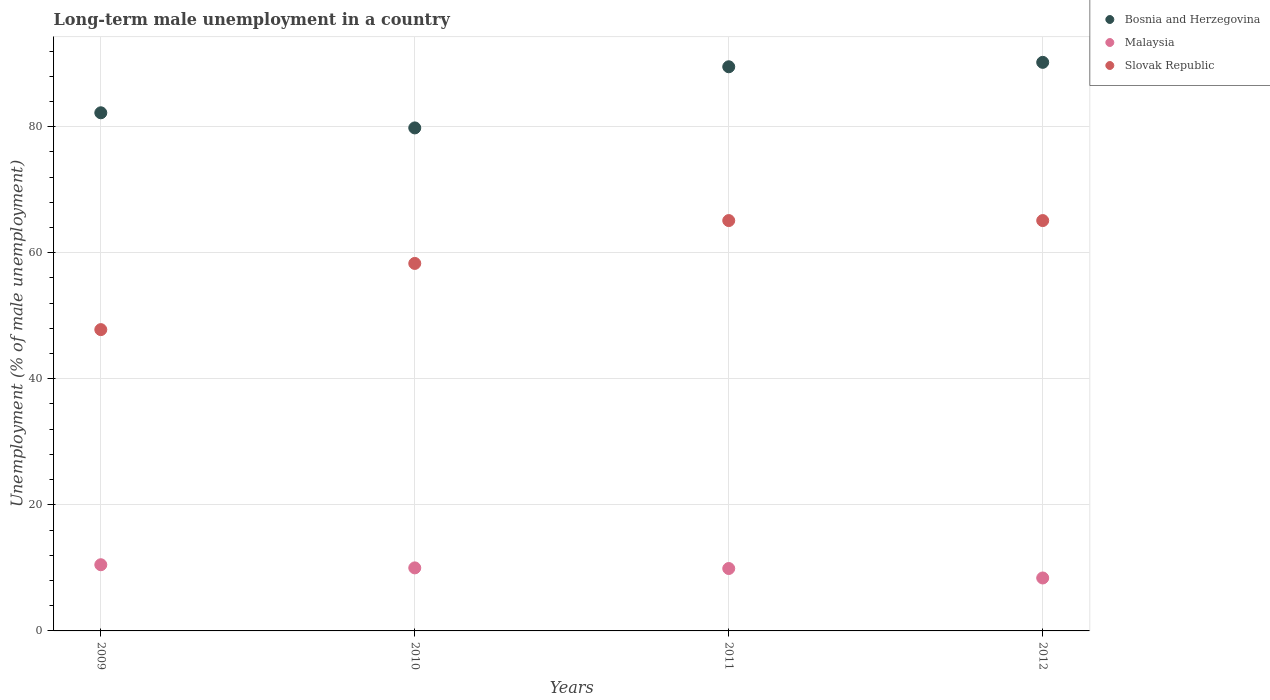How many different coloured dotlines are there?
Your response must be concise. 3. What is the percentage of long-term unemployed male population in Bosnia and Herzegovina in 2010?
Offer a very short reply. 79.8. Across all years, what is the maximum percentage of long-term unemployed male population in Slovak Republic?
Your answer should be very brief. 65.1. Across all years, what is the minimum percentage of long-term unemployed male population in Bosnia and Herzegovina?
Ensure brevity in your answer.  79.8. In which year was the percentage of long-term unemployed male population in Bosnia and Herzegovina maximum?
Provide a short and direct response. 2012. What is the total percentage of long-term unemployed male population in Bosnia and Herzegovina in the graph?
Give a very brief answer. 341.7. What is the difference between the percentage of long-term unemployed male population in Slovak Republic in 2009 and that in 2011?
Give a very brief answer. -17.3. What is the difference between the percentage of long-term unemployed male population in Malaysia in 2010 and the percentage of long-term unemployed male population in Slovak Republic in 2012?
Your response must be concise. -55.1. What is the average percentage of long-term unemployed male population in Slovak Republic per year?
Offer a terse response. 59.07. In the year 2012, what is the difference between the percentage of long-term unemployed male population in Bosnia and Herzegovina and percentage of long-term unemployed male population in Malaysia?
Offer a terse response. 81.8. In how many years, is the percentage of long-term unemployed male population in Bosnia and Herzegovina greater than 44 %?
Your answer should be compact. 4. What is the ratio of the percentage of long-term unemployed male population in Slovak Republic in 2009 to that in 2011?
Provide a short and direct response. 0.73. Is the percentage of long-term unemployed male population in Slovak Republic in 2009 less than that in 2011?
Provide a short and direct response. Yes. What is the difference between the highest and the second highest percentage of long-term unemployed male population in Bosnia and Herzegovina?
Give a very brief answer. 0.7. What is the difference between the highest and the lowest percentage of long-term unemployed male population in Slovak Republic?
Give a very brief answer. 17.3. Is it the case that in every year, the sum of the percentage of long-term unemployed male population in Bosnia and Herzegovina and percentage of long-term unemployed male population in Slovak Republic  is greater than the percentage of long-term unemployed male population in Malaysia?
Your answer should be very brief. Yes. Is the percentage of long-term unemployed male population in Malaysia strictly less than the percentage of long-term unemployed male population in Bosnia and Herzegovina over the years?
Offer a terse response. Yes. How many years are there in the graph?
Keep it short and to the point. 4. Are the values on the major ticks of Y-axis written in scientific E-notation?
Provide a short and direct response. No. Does the graph contain any zero values?
Provide a short and direct response. No. Does the graph contain grids?
Provide a succinct answer. Yes. Where does the legend appear in the graph?
Offer a very short reply. Top right. What is the title of the graph?
Provide a succinct answer. Long-term male unemployment in a country. Does "Paraguay" appear as one of the legend labels in the graph?
Your answer should be compact. No. What is the label or title of the Y-axis?
Your answer should be compact. Unemployment (% of male unemployment). What is the Unemployment (% of male unemployment) of Bosnia and Herzegovina in 2009?
Make the answer very short. 82.2. What is the Unemployment (% of male unemployment) in Malaysia in 2009?
Provide a short and direct response. 10.5. What is the Unemployment (% of male unemployment) in Slovak Republic in 2009?
Your answer should be very brief. 47.8. What is the Unemployment (% of male unemployment) of Bosnia and Herzegovina in 2010?
Offer a very short reply. 79.8. What is the Unemployment (% of male unemployment) in Slovak Republic in 2010?
Give a very brief answer. 58.3. What is the Unemployment (% of male unemployment) in Bosnia and Herzegovina in 2011?
Your answer should be very brief. 89.5. What is the Unemployment (% of male unemployment) of Malaysia in 2011?
Provide a short and direct response. 9.9. What is the Unemployment (% of male unemployment) of Slovak Republic in 2011?
Keep it short and to the point. 65.1. What is the Unemployment (% of male unemployment) in Bosnia and Herzegovina in 2012?
Give a very brief answer. 90.2. What is the Unemployment (% of male unemployment) of Malaysia in 2012?
Offer a terse response. 8.4. What is the Unemployment (% of male unemployment) in Slovak Republic in 2012?
Provide a short and direct response. 65.1. Across all years, what is the maximum Unemployment (% of male unemployment) in Bosnia and Herzegovina?
Offer a very short reply. 90.2. Across all years, what is the maximum Unemployment (% of male unemployment) of Slovak Republic?
Keep it short and to the point. 65.1. Across all years, what is the minimum Unemployment (% of male unemployment) in Bosnia and Herzegovina?
Offer a very short reply. 79.8. Across all years, what is the minimum Unemployment (% of male unemployment) of Malaysia?
Offer a very short reply. 8.4. Across all years, what is the minimum Unemployment (% of male unemployment) in Slovak Republic?
Your answer should be very brief. 47.8. What is the total Unemployment (% of male unemployment) of Bosnia and Herzegovina in the graph?
Your answer should be very brief. 341.7. What is the total Unemployment (% of male unemployment) of Malaysia in the graph?
Offer a terse response. 38.8. What is the total Unemployment (% of male unemployment) in Slovak Republic in the graph?
Provide a succinct answer. 236.3. What is the difference between the Unemployment (% of male unemployment) in Slovak Republic in 2009 and that in 2010?
Provide a short and direct response. -10.5. What is the difference between the Unemployment (% of male unemployment) of Slovak Republic in 2009 and that in 2011?
Offer a terse response. -17.3. What is the difference between the Unemployment (% of male unemployment) of Slovak Republic in 2009 and that in 2012?
Give a very brief answer. -17.3. What is the difference between the Unemployment (% of male unemployment) of Bosnia and Herzegovina in 2010 and that in 2011?
Your response must be concise. -9.7. What is the difference between the Unemployment (% of male unemployment) in Malaysia in 2010 and that in 2011?
Ensure brevity in your answer.  0.1. What is the difference between the Unemployment (% of male unemployment) of Slovak Republic in 2010 and that in 2011?
Your answer should be compact. -6.8. What is the difference between the Unemployment (% of male unemployment) of Bosnia and Herzegovina in 2010 and that in 2012?
Ensure brevity in your answer.  -10.4. What is the difference between the Unemployment (% of male unemployment) of Malaysia in 2010 and that in 2012?
Your answer should be compact. 1.6. What is the difference between the Unemployment (% of male unemployment) of Bosnia and Herzegovina in 2011 and that in 2012?
Provide a succinct answer. -0.7. What is the difference between the Unemployment (% of male unemployment) of Bosnia and Herzegovina in 2009 and the Unemployment (% of male unemployment) of Malaysia in 2010?
Give a very brief answer. 72.2. What is the difference between the Unemployment (% of male unemployment) in Bosnia and Herzegovina in 2009 and the Unemployment (% of male unemployment) in Slovak Republic in 2010?
Your answer should be very brief. 23.9. What is the difference between the Unemployment (% of male unemployment) of Malaysia in 2009 and the Unemployment (% of male unemployment) of Slovak Republic in 2010?
Make the answer very short. -47.8. What is the difference between the Unemployment (% of male unemployment) in Bosnia and Herzegovina in 2009 and the Unemployment (% of male unemployment) in Malaysia in 2011?
Your answer should be compact. 72.3. What is the difference between the Unemployment (% of male unemployment) in Bosnia and Herzegovina in 2009 and the Unemployment (% of male unemployment) in Slovak Republic in 2011?
Provide a short and direct response. 17.1. What is the difference between the Unemployment (% of male unemployment) of Malaysia in 2009 and the Unemployment (% of male unemployment) of Slovak Republic in 2011?
Provide a succinct answer. -54.6. What is the difference between the Unemployment (% of male unemployment) of Bosnia and Herzegovina in 2009 and the Unemployment (% of male unemployment) of Malaysia in 2012?
Offer a terse response. 73.8. What is the difference between the Unemployment (% of male unemployment) in Malaysia in 2009 and the Unemployment (% of male unemployment) in Slovak Republic in 2012?
Offer a terse response. -54.6. What is the difference between the Unemployment (% of male unemployment) of Bosnia and Herzegovina in 2010 and the Unemployment (% of male unemployment) of Malaysia in 2011?
Your answer should be very brief. 69.9. What is the difference between the Unemployment (% of male unemployment) of Bosnia and Herzegovina in 2010 and the Unemployment (% of male unemployment) of Slovak Republic in 2011?
Give a very brief answer. 14.7. What is the difference between the Unemployment (% of male unemployment) of Malaysia in 2010 and the Unemployment (% of male unemployment) of Slovak Republic in 2011?
Ensure brevity in your answer.  -55.1. What is the difference between the Unemployment (% of male unemployment) in Bosnia and Herzegovina in 2010 and the Unemployment (% of male unemployment) in Malaysia in 2012?
Keep it short and to the point. 71.4. What is the difference between the Unemployment (% of male unemployment) in Bosnia and Herzegovina in 2010 and the Unemployment (% of male unemployment) in Slovak Republic in 2012?
Make the answer very short. 14.7. What is the difference between the Unemployment (% of male unemployment) of Malaysia in 2010 and the Unemployment (% of male unemployment) of Slovak Republic in 2012?
Your response must be concise. -55.1. What is the difference between the Unemployment (% of male unemployment) in Bosnia and Herzegovina in 2011 and the Unemployment (% of male unemployment) in Malaysia in 2012?
Give a very brief answer. 81.1. What is the difference between the Unemployment (% of male unemployment) in Bosnia and Herzegovina in 2011 and the Unemployment (% of male unemployment) in Slovak Republic in 2012?
Your answer should be very brief. 24.4. What is the difference between the Unemployment (% of male unemployment) in Malaysia in 2011 and the Unemployment (% of male unemployment) in Slovak Republic in 2012?
Make the answer very short. -55.2. What is the average Unemployment (% of male unemployment) of Bosnia and Herzegovina per year?
Your answer should be compact. 85.42. What is the average Unemployment (% of male unemployment) of Slovak Republic per year?
Your response must be concise. 59.08. In the year 2009, what is the difference between the Unemployment (% of male unemployment) in Bosnia and Herzegovina and Unemployment (% of male unemployment) in Malaysia?
Provide a short and direct response. 71.7. In the year 2009, what is the difference between the Unemployment (% of male unemployment) in Bosnia and Herzegovina and Unemployment (% of male unemployment) in Slovak Republic?
Your answer should be very brief. 34.4. In the year 2009, what is the difference between the Unemployment (% of male unemployment) of Malaysia and Unemployment (% of male unemployment) of Slovak Republic?
Offer a very short reply. -37.3. In the year 2010, what is the difference between the Unemployment (% of male unemployment) of Bosnia and Herzegovina and Unemployment (% of male unemployment) of Malaysia?
Provide a short and direct response. 69.8. In the year 2010, what is the difference between the Unemployment (% of male unemployment) of Bosnia and Herzegovina and Unemployment (% of male unemployment) of Slovak Republic?
Keep it short and to the point. 21.5. In the year 2010, what is the difference between the Unemployment (% of male unemployment) of Malaysia and Unemployment (% of male unemployment) of Slovak Republic?
Offer a very short reply. -48.3. In the year 2011, what is the difference between the Unemployment (% of male unemployment) in Bosnia and Herzegovina and Unemployment (% of male unemployment) in Malaysia?
Provide a succinct answer. 79.6. In the year 2011, what is the difference between the Unemployment (% of male unemployment) of Bosnia and Herzegovina and Unemployment (% of male unemployment) of Slovak Republic?
Provide a succinct answer. 24.4. In the year 2011, what is the difference between the Unemployment (% of male unemployment) of Malaysia and Unemployment (% of male unemployment) of Slovak Republic?
Make the answer very short. -55.2. In the year 2012, what is the difference between the Unemployment (% of male unemployment) of Bosnia and Herzegovina and Unemployment (% of male unemployment) of Malaysia?
Offer a very short reply. 81.8. In the year 2012, what is the difference between the Unemployment (% of male unemployment) of Bosnia and Herzegovina and Unemployment (% of male unemployment) of Slovak Republic?
Ensure brevity in your answer.  25.1. In the year 2012, what is the difference between the Unemployment (% of male unemployment) of Malaysia and Unemployment (% of male unemployment) of Slovak Republic?
Provide a short and direct response. -56.7. What is the ratio of the Unemployment (% of male unemployment) of Bosnia and Herzegovina in 2009 to that in 2010?
Give a very brief answer. 1.03. What is the ratio of the Unemployment (% of male unemployment) in Slovak Republic in 2009 to that in 2010?
Offer a terse response. 0.82. What is the ratio of the Unemployment (% of male unemployment) of Bosnia and Herzegovina in 2009 to that in 2011?
Provide a succinct answer. 0.92. What is the ratio of the Unemployment (% of male unemployment) of Malaysia in 2009 to that in 2011?
Your answer should be compact. 1.06. What is the ratio of the Unemployment (% of male unemployment) of Slovak Republic in 2009 to that in 2011?
Your answer should be compact. 0.73. What is the ratio of the Unemployment (% of male unemployment) in Bosnia and Herzegovina in 2009 to that in 2012?
Your response must be concise. 0.91. What is the ratio of the Unemployment (% of male unemployment) of Slovak Republic in 2009 to that in 2012?
Ensure brevity in your answer.  0.73. What is the ratio of the Unemployment (% of male unemployment) in Bosnia and Herzegovina in 2010 to that in 2011?
Offer a very short reply. 0.89. What is the ratio of the Unemployment (% of male unemployment) of Slovak Republic in 2010 to that in 2011?
Make the answer very short. 0.9. What is the ratio of the Unemployment (% of male unemployment) of Bosnia and Herzegovina in 2010 to that in 2012?
Make the answer very short. 0.88. What is the ratio of the Unemployment (% of male unemployment) in Malaysia in 2010 to that in 2012?
Provide a short and direct response. 1.19. What is the ratio of the Unemployment (% of male unemployment) of Slovak Republic in 2010 to that in 2012?
Provide a succinct answer. 0.9. What is the ratio of the Unemployment (% of male unemployment) in Bosnia and Herzegovina in 2011 to that in 2012?
Your answer should be very brief. 0.99. What is the ratio of the Unemployment (% of male unemployment) of Malaysia in 2011 to that in 2012?
Offer a terse response. 1.18. What is the ratio of the Unemployment (% of male unemployment) of Slovak Republic in 2011 to that in 2012?
Keep it short and to the point. 1. What is the difference between the highest and the second highest Unemployment (% of male unemployment) in Bosnia and Herzegovina?
Provide a short and direct response. 0.7. What is the difference between the highest and the second highest Unemployment (% of male unemployment) of Malaysia?
Your answer should be compact. 0.5. What is the difference between the highest and the second highest Unemployment (% of male unemployment) in Slovak Republic?
Ensure brevity in your answer.  0. What is the difference between the highest and the lowest Unemployment (% of male unemployment) of Bosnia and Herzegovina?
Your response must be concise. 10.4. What is the difference between the highest and the lowest Unemployment (% of male unemployment) in Slovak Republic?
Offer a terse response. 17.3. 